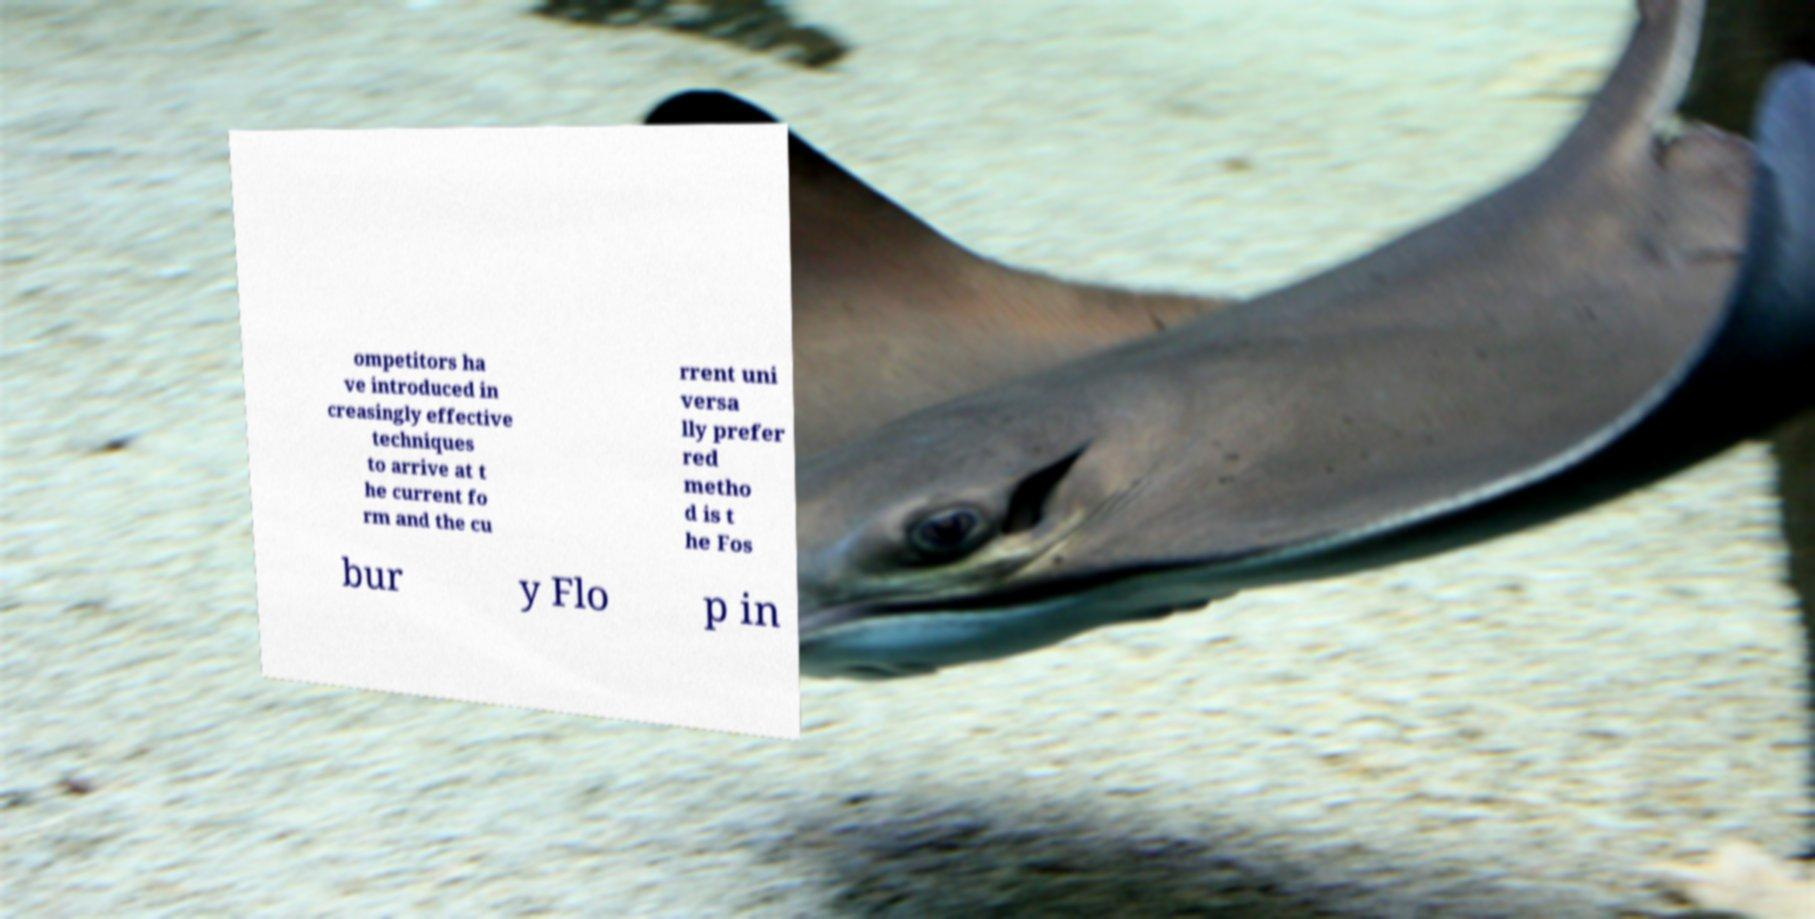Can you read and provide the text displayed in the image?This photo seems to have some interesting text. Can you extract and type it out for me? ompetitors ha ve introduced in creasingly effective techniques to arrive at t he current fo rm and the cu rrent uni versa lly prefer red metho d is t he Fos bur y Flo p in 